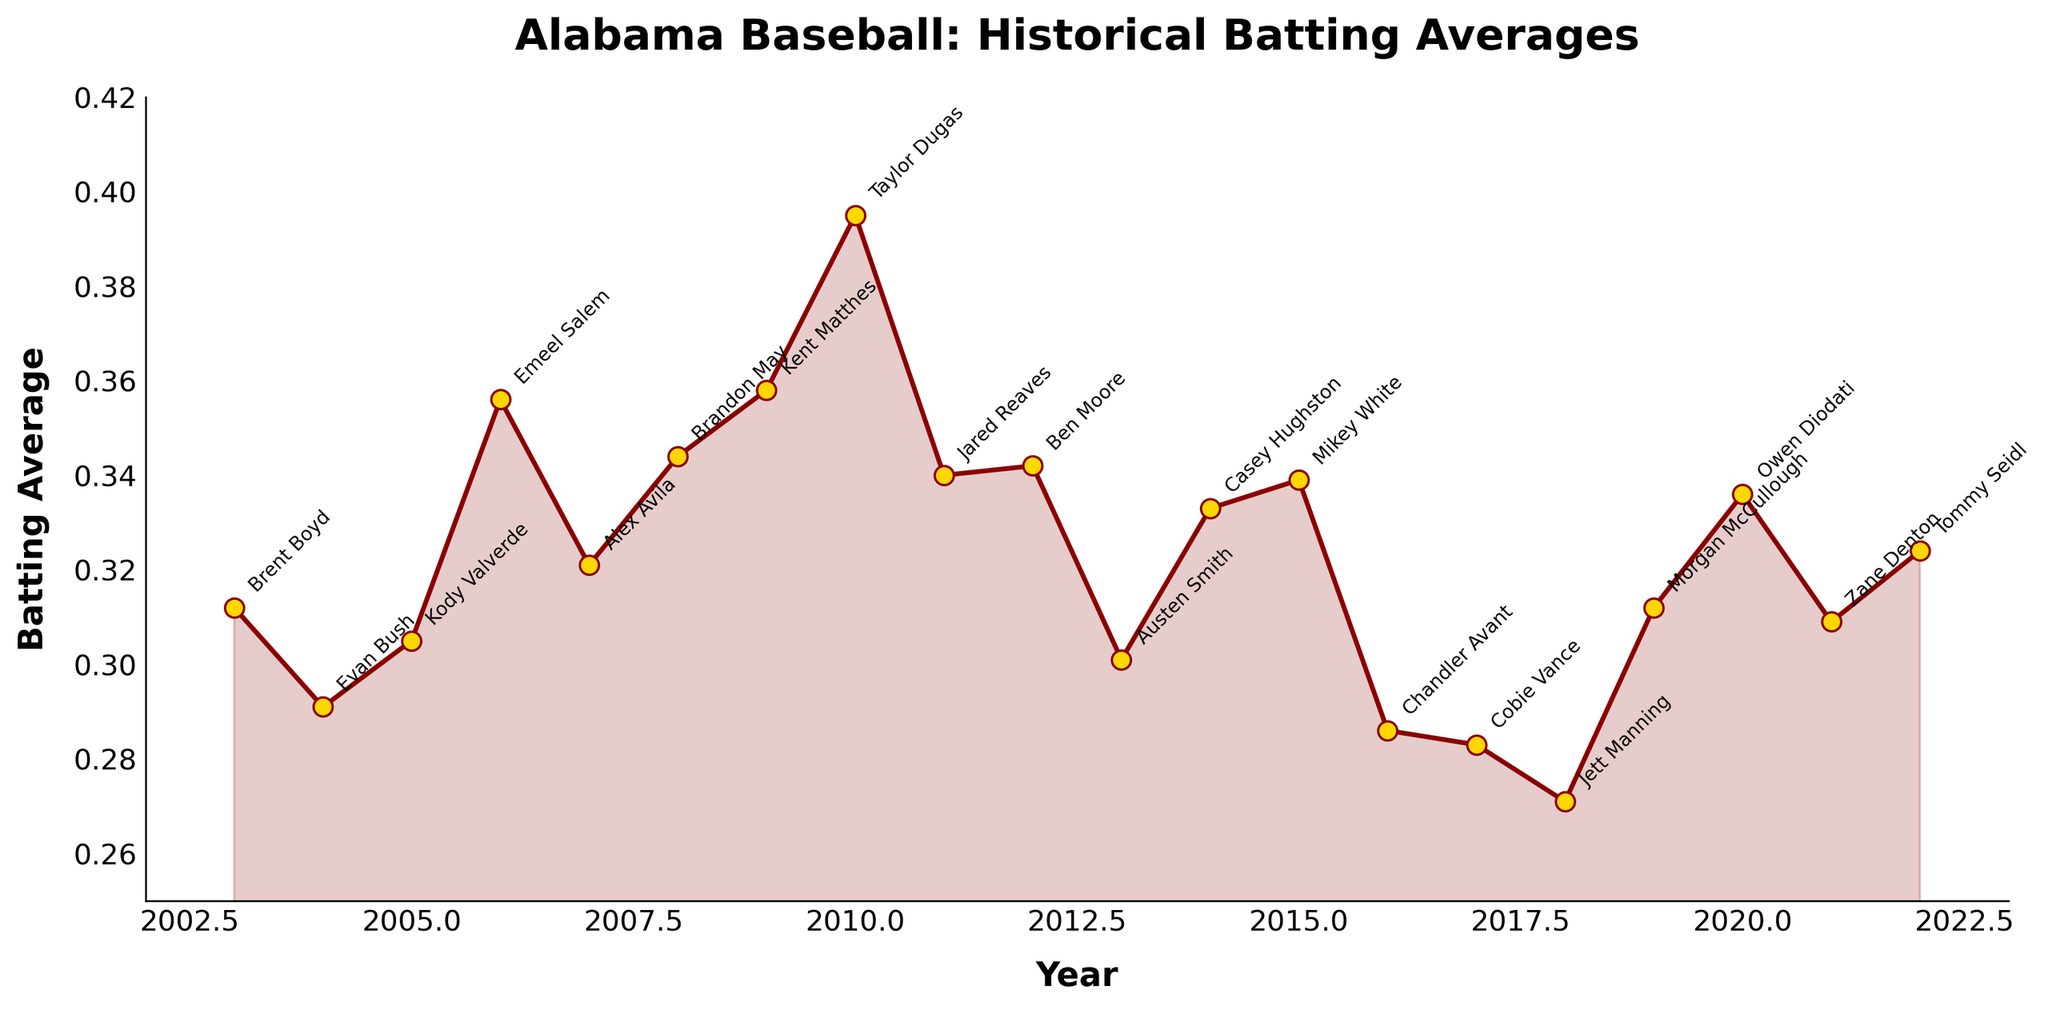What's the title of the plot? The title of the plot is found at the top and describes the overall content. It helps provide context for the data being visualized.
Answer: Alabama Baseball: Historical Batting Averages Which year has the highest batting average shown in the plot? The highest batting average is represented by the tallest data point on the y-axis. Looking at the values, the highest point is near 0.395, occurring in the year 2010.
Answer: 2010 How many players have batting averages annotated on the plot? Each data point is annotated with the name of a player. Counting these annotations gives the total number of players. There are 20 data points annotated.
Answer: 20 What's the difference in batting averages between the years 2004 and 2007? First, identify the batting averages for 2004 and 2007. Then, subtract the 2004 average from the 2007 average: 0.321 (2007) - 0.291 (2004).
Answer: 0.030 Which player had the lowest batting average, and in which year? The lowest batting average is the smallest data point on the y-axis. By finding this point, we see that it is approximately 0.271, annotated as Jett Manning in 2018.
Answer: Jett Manning, 2018 What is the average batting average over the 20 years shown on the plot? Sum all the batting averages and divide by the total number of data points (20). (0.312 + 0.291 + 0.305 + 0.356 + 0.321 + 0.344 + 0.358 + 0.395 + 0.340 + 0.342 + 0.301 + 0.333 + 0.339 + 0.286 + 0.283 + 0.271 + 0.312 + 0.336 + 0.309 + 0.324) / 20 = 6.365/20 = 0.31825
Answer: 0.31825 Which years show a batting average greater than 0.350? Look at all the data points above the 0.350 mark on the y-axis. These occur in the years 2006, 2009, and 2010 with averages 0.356, 0.358, and 0.395 respectively.
Answer: 2006, 2009, 2010 How does the batting average in 2010 compare to the average in 2004 and 2005 combined? First, find the average of 2004 and 2005: (0.291+0.305)/2 = 0.298. Compare this to the 2010 value of 0.395. Since 0.395 is greater than 0.298, the batting average in 2010 is higher.
Answer: Higher What's the trend in batting averages from 2016 to 2018? Observing the plot from 2016 to 2018, the batting averages decrease from 0.286 in 2016, to 0.283 in 2017, and to 0.271 in 2018.
Answer: Decreasing 